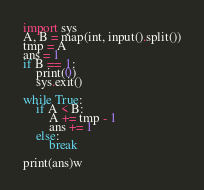<code> <loc_0><loc_0><loc_500><loc_500><_Python_>import sys
A, B = map(int, input().split())
tmp = A
ans = 1
if B == 1:
    print(0)
    sys.exit()

while True:
    if A < B:
        A += tmp - 1
        ans += 1
    else:
        break

print(ans)w</code> 